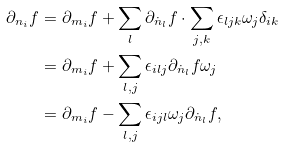<formula> <loc_0><loc_0><loc_500><loc_500>\partial _ { n _ { i } } f & = \partial _ { m _ { i } } f + \sum _ { l } \partial _ { \dot { n } _ { l } } f \cdot \sum _ { j , k } \epsilon _ { l j k } \omega _ { j } \delta _ { i k } \\ & = \partial _ { m _ { i } } f + \sum _ { l , j } \epsilon _ { i l j } \partial _ { \dot { n } _ { l } } f \omega _ { j } \\ & = \partial _ { m _ { i } } f - \sum _ { l , j } \epsilon _ { i j l } \omega _ { j } \partial _ { \dot { n } _ { l } } f ,</formula> 